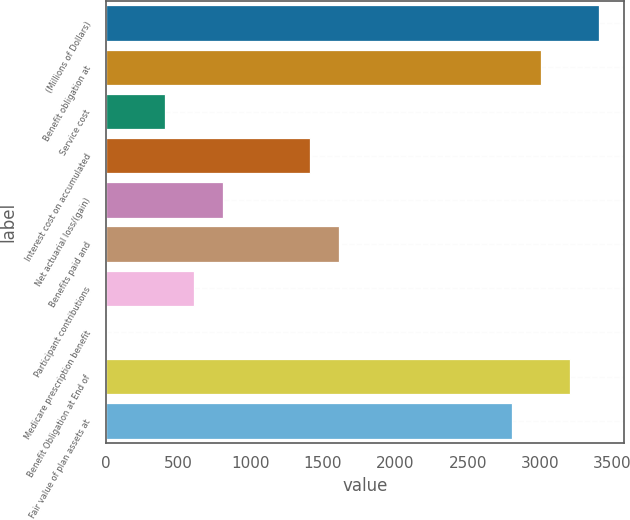Convert chart to OTSL. <chart><loc_0><loc_0><loc_500><loc_500><bar_chart><fcel>(Millions of Dollars)<fcel>Benefit obligation at<fcel>Service cost<fcel>Interest cost on accumulated<fcel>Net actuarial loss/(gain)<fcel>Benefits paid and<fcel>Participant contributions<fcel>Medicare prescription benefit<fcel>Benefit Obligation at End of<fcel>Fair value of plan assets at<nl><fcel>3410.1<fcel>3009.5<fcel>405.6<fcel>1407.1<fcel>806.2<fcel>1607.4<fcel>605.9<fcel>5<fcel>3209.8<fcel>2809.2<nl></chart> 